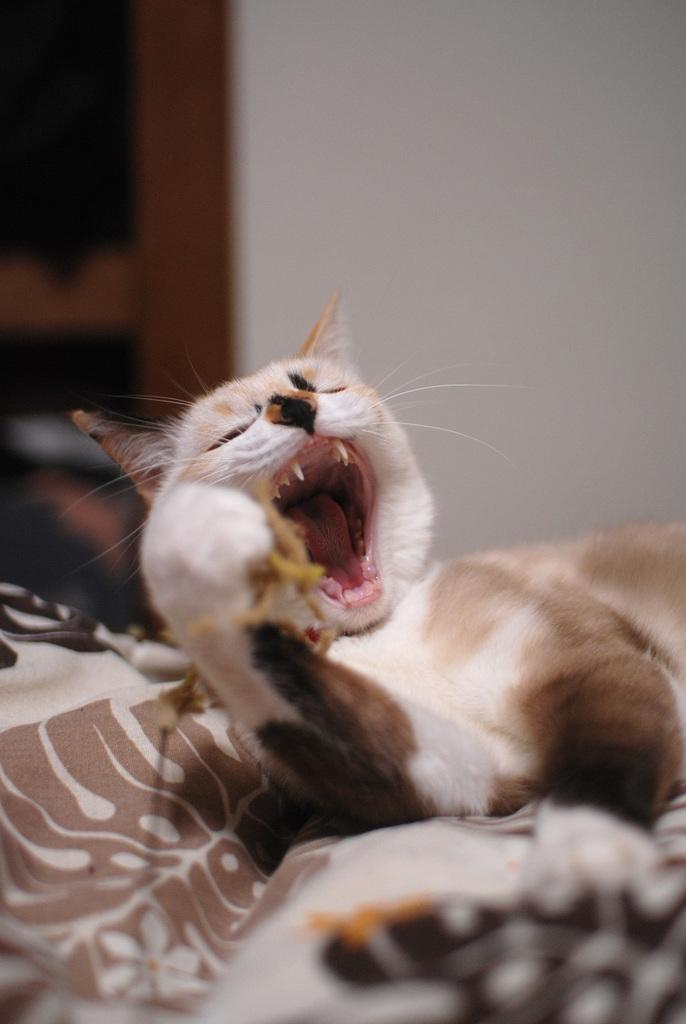What animal is present in the image? There is a cat in the image. What is the cat lying on? The cat is lying on a cloth. What is the cat's mouth doing in the image? The cat's mouth is wide open. What can be seen in the background of the image? There is a wall in the background of the image. What is the price of the quicksand in the image? There is no quicksand present in the image, so it is not possible to determine its price. 